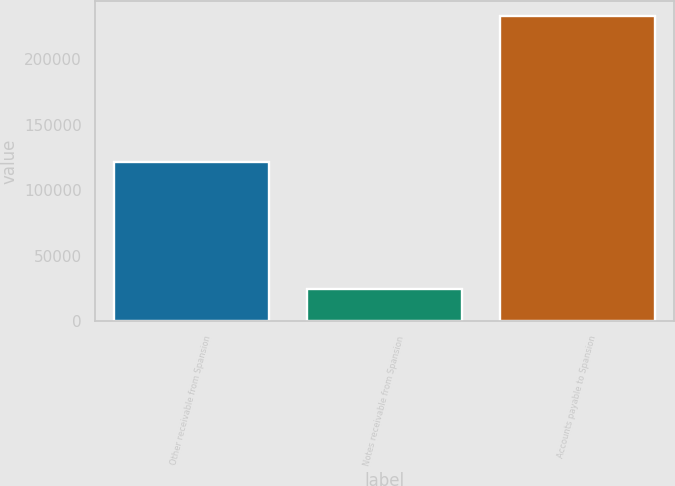Convert chart. <chart><loc_0><loc_0><loc_500><loc_500><bar_chart><fcel>Other receivable from Spansion<fcel>Notes receivable from Spansion<fcel>Accounts payable to Spansion<nl><fcel>121585<fcel>25008<fcel>233224<nl></chart> 